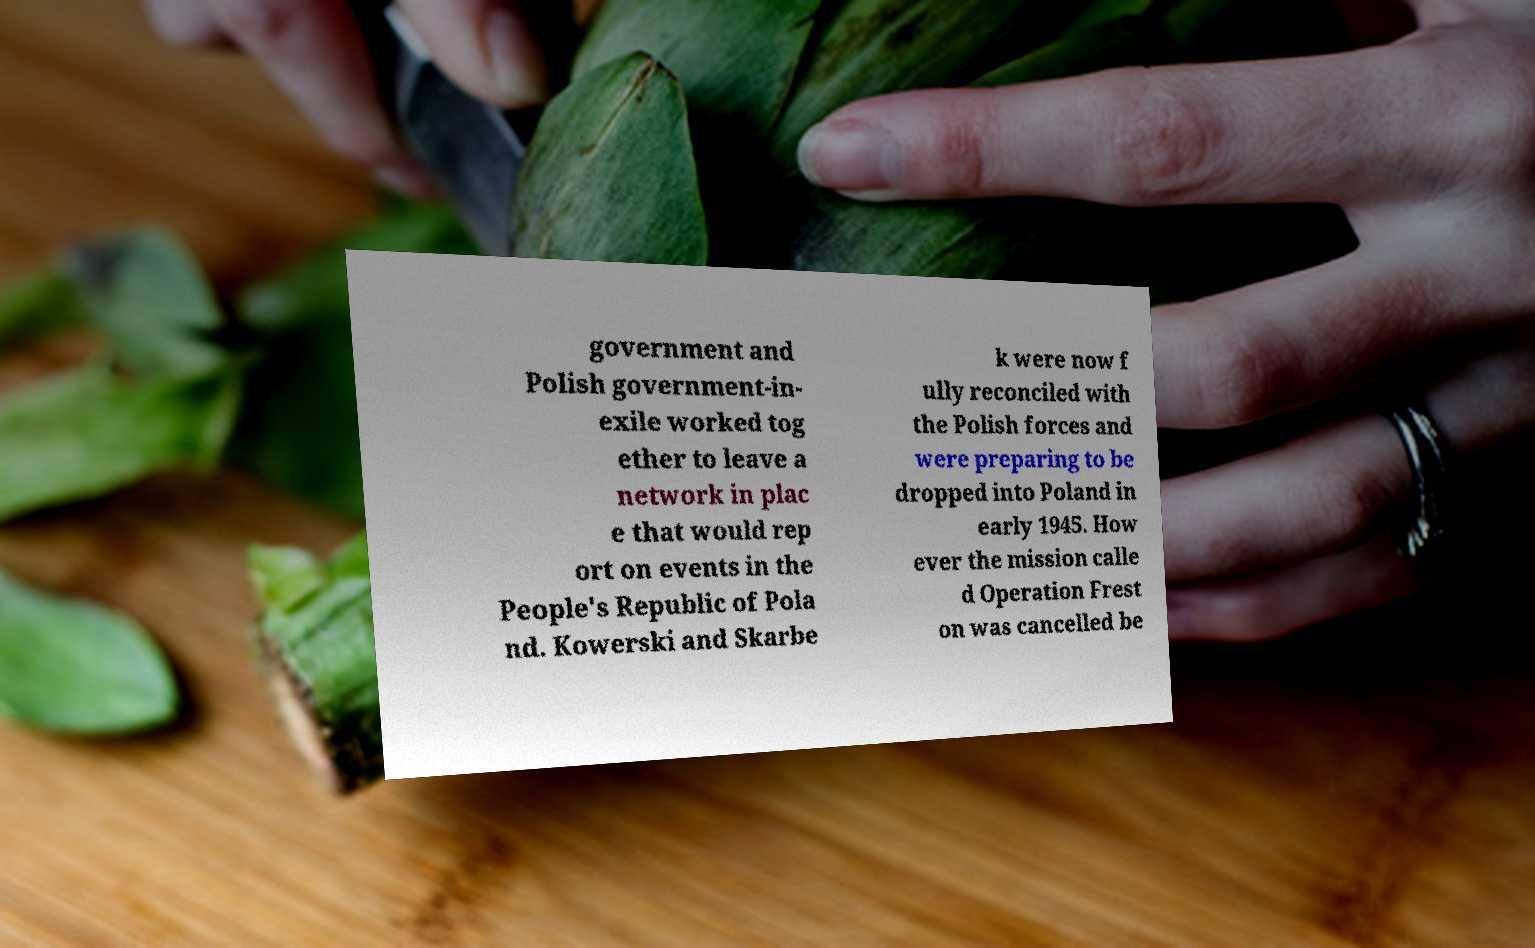Can you accurately transcribe the text from the provided image for me? government and Polish government-in- exile worked tog ether to leave a network in plac e that would rep ort on events in the People's Republic of Pola nd. Kowerski and Skarbe k were now f ully reconciled with the Polish forces and were preparing to be dropped into Poland in early 1945. How ever the mission calle d Operation Frest on was cancelled be 